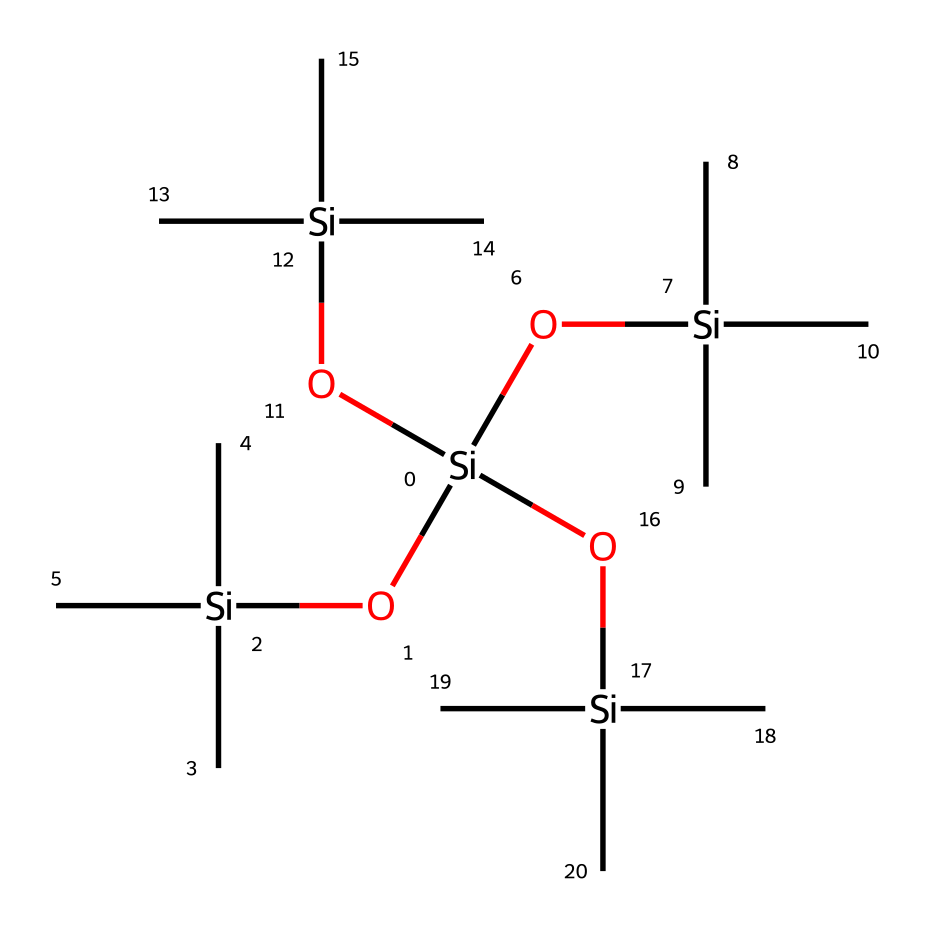What is the main element in this chemical structure? The structure prominently features silicon (Si) atoms, which are at the center of each branched siloxane group. There are multiple silicon atoms present that define it as an organosilicon compound.
Answer: silicon How many silicon atoms are present in the structure? By examining the SMILES representation, it is clear that there are five distinct silicon atoms indicated by the recurring '[Si]' notation. Each branching corresponds to a silicon atom.
Answer: five What type of bonding is predominantly found in this structure? The structure forms siloxane linkages (-Si-O-Si-) that indicate strong covalent bonds between the silicon and oxygen atoms. This is a characteristic feature of organosilicon compounds.
Answer: covalent What functional groups can be identified in this chemical? The chemical contains silanol groups (-Si-OH) as indicated by the presence of silicon atoms attached to hydroxy groups. These functional groups are characteristic of silicone materials and inks.
Answer: silanol Based on its structure, what aspect of this chemical enhances its ink properties? The branched siloxane structure provides viscosity and flexibility, which are essential for good flow and stability in printing inks. This chemical's organization allows it to adhere well to various substrates.
Answer: viscosity and flexibility What is the overall classification of this compound? Due to its silicon-based structure featuring siloxane linkages and organic groups, it is classified as an organosilicon compound, commonly used in different applications including inks.
Answer: organosilicon 